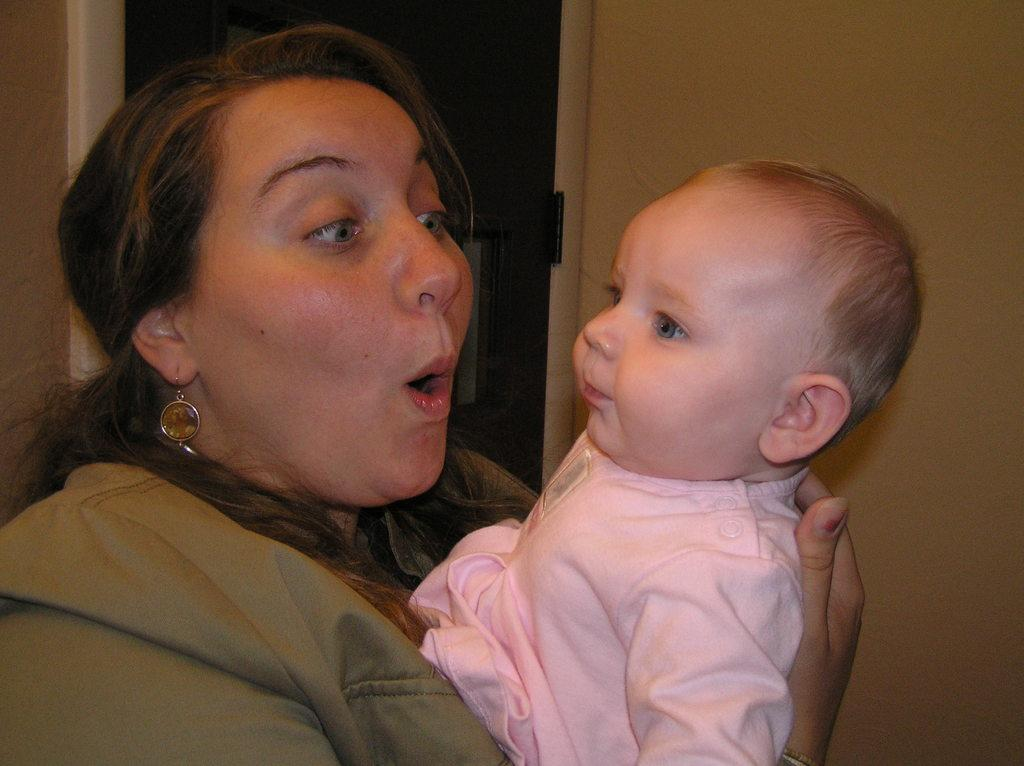Who is present in the image? There is a woman in the image. What is the woman doing in the image? The woman is holding a child. What architectural features can be seen in the image? There is a door and a wall in the image. What type of rose is being advertised in the image? There is no rose or advertisement present in the image. What is the woman using to whip the child in the image? The woman is not whipping the child in the image; she is holding the child. 